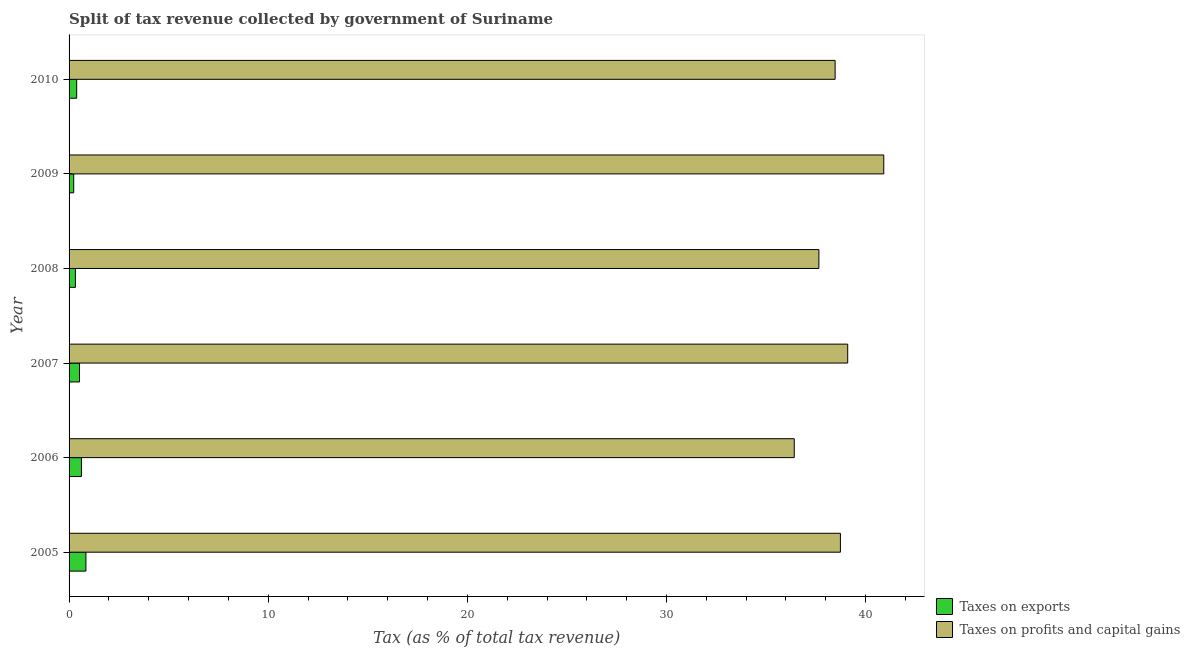How many groups of bars are there?
Your answer should be compact. 6. Are the number of bars on each tick of the Y-axis equal?
Make the answer very short. Yes. In how many cases, is the number of bars for a given year not equal to the number of legend labels?
Make the answer very short. 0. What is the percentage of revenue obtained from taxes on exports in 2008?
Offer a very short reply. 0.32. Across all years, what is the maximum percentage of revenue obtained from taxes on profits and capital gains?
Your response must be concise. 40.91. Across all years, what is the minimum percentage of revenue obtained from taxes on profits and capital gains?
Offer a very short reply. 36.42. What is the total percentage of revenue obtained from taxes on exports in the graph?
Your response must be concise. 2.92. What is the difference between the percentage of revenue obtained from taxes on profits and capital gains in 2005 and that in 2007?
Your answer should be compact. -0.37. What is the difference between the percentage of revenue obtained from taxes on profits and capital gains in 2008 and the percentage of revenue obtained from taxes on exports in 2005?
Your answer should be very brief. 36.81. What is the average percentage of revenue obtained from taxes on exports per year?
Offer a terse response. 0.49. In the year 2010, what is the difference between the percentage of revenue obtained from taxes on profits and capital gains and percentage of revenue obtained from taxes on exports?
Provide a short and direct response. 38.09. In how many years, is the percentage of revenue obtained from taxes on exports greater than 16 %?
Your answer should be compact. 0. What is the ratio of the percentage of revenue obtained from taxes on profits and capital gains in 2006 to that in 2009?
Ensure brevity in your answer.  0.89. Is the difference between the percentage of revenue obtained from taxes on exports in 2009 and 2010 greater than the difference between the percentage of revenue obtained from taxes on profits and capital gains in 2009 and 2010?
Give a very brief answer. No. What is the difference between the highest and the second highest percentage of revenue obtained from taxes on profits and capital gains?
Ensure brevity in your answer.  1.81. What is the difference between the highest and the lowest percentage of revenue obtained from taxes on profits and capital gains?
Ensure brevity in your answer.  4.49. In how many years, is the percentage of revenue obtained from taxes on profits and capital gains greater than the average percentage of revenue obtained from taxes on profits and capital gains taken over all years?
Offer a very short reply. 3. Is the sum of the percentage of revenue obtained from taxes on profits and capital gains in 2007 and 2008 greater than the maximum percentage of revenue obtained from taxes on exports across all years?
Keep it short and to the point. Yes. What does the 1st bar from the top in 2006 represents?
Your answer should be compact. Taxes on profits and capital gains. What does the 1st bar from the bottom in 2005 represents?
Keep it short and to the point. Taxes on exports. How many bars are there?
Provide a short and direct response. 12. Are all the bars in the graph horizontal?
Offer a terse response. Yes. How many years are there in the graph?
Offer a terse response. 6. What is the difference between two consecutive major ticks on the X-axis?
Offer a very short reply. 10. Are the values on the major ticks of X-axis written in scientific E-notation?
Ensure brevity in your answer.  No. Does the graph contain any zero values?
Offer a very short reply. No. Does the graph contain grids?
Provide a succinct answer. No. How many legend labels are there?
Make the answer very short. 2. How are the legend labels stacked?
Your answer should be very brief. Vertical. What is the title of the graph?
Your answer should be compact. Split of tax revenue collected by government of Suriname. Does "Health Care" appear as one of the legend labels in the graph?
Offer a terse response. No. What is the label or title of the X-axis?
Your answer should be very brief. Tax (as % of total tax revenue). What is the Tax (as % of total tax revenue) in Taxes on exports in 2005?
Your response must be concise. 0.85. What is the Tax (as % of total tax revenue) of Taxes on profits and capital gains in 2005?
Your response must be concise. 38.73. What is the Tax (as % of total tax revenue) in Taxes on exports in 2006?
Provide a short and direct response. 0.62. What is the Tax (as % of total tax revenue) in Taxes on profits and capital gains in 2006?
Provide a short and direct response. 36.42. What is the Tax (as % of total tax revenue) in Taxes on exports in 2007?
Give a very brief answer. 0.52. What is the Tax (as % of total tax revenue) of Taxes on profits and capital gains in 2007?
Your response must be concise. 39.1. What is the Tax (as % of total tax revenue) of Taxes on exports in 2008?
Offer a very short reply. 0.32. What is the Tax (as % of total tax revenue) of Taxes on profits and capital gains in 2008?
Provide a short and direct response. 37.65. What is the Tax (as % of total tax revenue) of Taxes on exports in 2009?
Ensure brevity in your answer.  0.23. What is the Tax (as % of total tax revenue) of Taxes on profits and capital gains in 2009?
Your response must be concise. 40.91. What is the Tax (as % of total tax revenue) in Taxes on exports in 2010?
Keep it short and to the point. 0.38. What is the Tax (as % of total tax revenue) in Taxes on profits and capital gains in 2010?
Your answer should be compact. 38.47. Across all years, what is the maximum Tax (as % of total tax revenue) of Taxes on exports?
Provide a short and direct response. 0.85. Across all years, what is the maximum Tax (as % of total tax revenue) in Taxes on profits and capital gains?
Your response must be concise. 40.91. Across all years, what is the minimum Tax (as % of total tax revenue) in Taxes on exports?
Keep it short and to the point. 0.23. Across all years, what is the minimum Tax (as % of total tax revenue) in Taxes on profits and capital gains?
Make the answer very short. 36.42. What is the total Tax (as % of total tax revenue) of Taxes on exports in the graph?
Your answer should be compact. 2.92. What is the total Tax (as % of total tax revenue) in Taxes on profits and capital gains in the graph?
Make the answer very short. 231.28. What is the difference between the Tax (as % of total tax revenue) of Taxes on exports in 2005 and that in 2006?
Keep it short and to the point. 0.23. What is the difference between the Tax (as % of total tax revenue) of Taxes on profits and capital gains in 2005 and that in 2006?
Offer a very short reply. 2.32. What is the difference between the Tax (as % of total tax revenue) of Taxes on exports in 2005 and that in 2007?
Provide a succinct answer. 0.32. What is the difference between the Tax (as % of total tax revenue) in Taxes on profits and capital gains in 2005 and that in 2007?
Ensure brevity in your answer.  -0.37. What is the difference between the Tax (as % of total tax revenue) of Taxes on exports in 2005 and that in 2008?
Provide a short and direct response. 0.53. What is the difference between the Tax (as % of total tax revenue) of Taxes on profits and capital gains in 2005 and that in 2008?
Your response must be concise. 1.08. What is the difference between the Tax (as % of total tax revenue) in Taxes on exports in 2005 and that in 2009?
Provide a succinct answer. 0.61. What is the difference between the Tax (as % of total tax revenue) of Taxes on profits and capital gains in 2005 and that in 2009?
Provide a succinct answer. -2.18. What is the difference between the Tax (as % of total tax revenue) of Taxes on exports in 2005 and that in 2010?
Your response must be concise. 0.46. What is the difference between the Tax (as % of total tax revenue) in Taxes on profits and capital gains in 2005 and that in 2010?
Provide a succinct answer. 0.27. What is the difference between the Tax (as % of total tax revenue) of Taxes on exports in 2006 and that in 2007?
Your response must be concise. 0.1. What is the difference between the Tax (as % of total tax revenue) of Taxes on profits and capital gains in 2006 and that in 2007?
Offer a terse response. -2.68. What is the difference between the Tax (as % of total tax revenue) of Taxes on exports in 2006 and that in 2008?
Provide a short and direct response. 0.3. What is the difference between the Tax (as % of total tax revenue) of Taxes on profits and capital gains in 2006 and that in 2008?
Provide a succinct answer. -1.24. What is the difference between the Tax (as % of total tax revenue) in Taxes on exports in 2006 and that in 2009?
Make the answer very short. 0.39. What is the difference between the Tax (as % of total tax revenue) in Taxes on profits and capital gains in 2006 and that in 2009?
Provide a short and direct response. -4.49. What is the difference between the Tax (as % of total tax revenue) of Taxes on exports in 2006 and that in 2010?
Your response must be concise. 0.24. What is the difference between the Tax (as % of total tax revenue) of Taxes on profits and capital gains in 2006 and that in 2010?
Provide a succinct answer. -2.05. What is the difference between the Tax (as % of total tax revenue) of Taxes on exports in 2007 and that in 2008?
Ensure brevity in your answer.  0.2. What is the difference between the Tax (as % of total tax revenue) of Taxes on profits and capital gains in 2007 and that in 2008?
Your answer should be very brief. 1.45. What is the difference between the Tax (as % of total tax revenue) of Taxes on exports in 2007 and that in 2009?
Keep it short and to the point. 0.29. What is the difference between the Tax (as % of total tax revenue) of Taxes on profits and capital gains in 2007 and that in 2009?
Ensure brevity in your answer.  -1.81. What is the difference between the Tax (as % of total tax revenue) in Taxes on exports in 2007 and that in 2010?
Make the answer very short. 0.14. What is the difference between the Tax (as % of total tax revenue) in Taxes on profits and capital gains in 2007 and that in 2010?
Provide a short and direct response. 0.63. What is the difference between the Tax (as % of total tax revenue) in Taxes on exports in 2008 and that in 2009?
Keep it short and to the point. 0.09. What is the difference between the Tax (as % of total tax revenue) in Taxes on profits and capital gains in 2008 and that in 2009?
Provide a succinct answer. -3.26. What is the difference between the Tax (as % of total tax revenue) of Taxes on exports in 2008 and that in 2010?
Give a very brief answer. -0.06. What is the difference between the Tax (as % of total tax revenue) of Taxes on profits and capital gains in 2008 and that in 2010?
Your answer should be very brief. -0.81. What is the difference between the Tax (as % of total tax revenue) of Taxes on exports in 2009 and that in 2010?
Provide a succinct answer. -0.15. What is the difference between the Tax (as % of total tax revenue) in Taxes on profits and capital gains in 2009 and that in 2010?
Keep it short and to the point. 2.44. What is the difference between the Tax (as % of total tax revenue) of Taxes on exports in 2005 and the Tax (as % of total tax revenue) of Taxes on profits and capital gains in 2006?
Keep it short and to the point. -35.57. What is the difference between the Tax (as % of total tax revenue) of Taxes on exports in 2005 and the Tax (as % of total tax revenue) of Taxes on profits and capital gains in 2007?
Provide a succinct answer. -38.25. What is the difference between the Tax (as % of total tax revenue) in Taxes on exports in 2005 and the Tax (as % of total tax revenue) in Taxes on profits and capital gains in 2008?
Offer a very short reply. -36.81. What is the difference between the Tax (as % of total tax revenue) of Taxes on exports in 2005 and the Tax (as % of total tax revenue) of Taxes on profits and capital gains in 2009?
Your answer should be very brief. -40.06. What is the difference between the Tax (as % of total tax revenue) of Taxes on exports in 2005 and the Tax (as % of total tax revenue) of Taxes on profits and capital gains in 2010?
Keep it short and to the point. -37.62. What is the difference between the Tax (as % of total tax revenue) in Taxes on exports in 2006 and the Tax (as % of total tax revenue) in Taxes on profits and capital gains in 2007?
Provide a succinct answer. -38.48. What is the difference between the Tax (as % of total tax revenue) in Taxes on exports in 2006 and the Tax (as % of total tax revenue) in Taxes on profits and capital gains in 2008?
Your response must be concise. -37.03. What is the difference between the Tax (as % of total tax revenue) of Taxes on exports in 2006 and the Tax (as % of total tax revenue) of Taxes on profits and capital gains in 2009?
Offer a very short reply. -40.29. What is the difference between the Tax (as % of total tax revenue) in Taxes on exports in 2006 and the Tax (as % of total tax revenue) in Taxes on profits and capital gains in 2010?
Offer a terse response. -37.85. What is the difference between the Tax (as % of total tax revenue) of Taxes on exports in 2007 and the Tax (as % of total tax revenue) of Taxes on profits and capital gains in 2008?
Give a very brief answer. -37.13. What is the difference between the Tax (as % of total tax revenue) of Taxes on exports in 2007 and the Tax (as % of total tax revenue) of Taxes on profits and capital gains in 2009?
Keep it short and to the point. -40.39. What is the difference between the Tax (as % of total tax revenue) in Taxes on exports in 2007 and the Tax (as % of total tax revenue) in Taxes on profits and capital gains in 2010?
Offer a very short reply. -37.95. What is the difference between the Tax (as % of total tax revenue) in Taxes on exports in 2008 and the Tax (as % of total tax revenue) in Taxes on profits and capital gains in 2009?
Offer a terse response. -40.59. What is the difference between the Tax (as % of total tax revenue) in Taxes on exports in 2008 and the Tax (as % of total tax revenue) in Taxes on profits and capital gains in 2010?
Your response must be concise. -38.15. What is the difference between the Tax (as % of total tax revenue) of Taxes on exports in 2009 and the Tax (as % of total tax revenue) of Taxes on profits and capital gains in 2010?
Offer a terse response. -38.23. What is the average Tax (as % of total tax revenue) in Taxes on exports per year?
Offer a very short reply. 0.49. What is the average Tax (as % of total tax revenue) of Taxes on profits and capital gains per year?
Make the answer very short. 38.55. In the year 2005, what is the difference between the Tax (as % of total tax revenue) in Taxes on exports and Tax (as % of total tax revenue) in Taxes on profits and capital gains?
Keep it short and to the point. -37.89. In the year 2006, what is the difference between the Tax (as % of total tax revenue) in Taxes on exports and Tax (as % of total tax revenue) in Taxes on profits and capital gains?
Offer a terse response. -35.79. In the year 2007, what is the difference between the Tax (as % of total tax revenue) in Taxes on exports and Tax (as % of total tax revenue) in Taxes on profits and capital gains?
Make the answer very short. -38.58. In the year 2008, what is the difference between the Tax (as % of total tax revenue) in Taxes on exports and Tax (as % of total tax revenue) in Taxes on profits and capital gains?
Provide a succinct answer. -37.34. In the year 2009, what is the difference between the Tax (as % of total tax revenue) in Taxes on exports and Tax (as % of total tax revenue) in Taxes on profits and capital gains?
Offer a terse response. -40.68. In the year 2010, what is the difference between the Tax (as % of total tax revenue) of Taxes on exports and Tax (as % of total tax revenue) of Taxes on profits and capital gains?
Provide a succinct answer. -38.09. What is the ratio of the Tax (as % of total tax revenue) in Taxes on exports in 2005 to that in 2006?
Your response must be concise. 1.36. What is the ratio of the Tax (as % of total tax revenue) of Taxes on profits and capital gains in 2005 to that in 2006?
Your answer should be compact. 1.06. What is the ratio of the Tax (as % of total tax revenue) of Taxes on exports in 2005 to that in 2007?
Your answer should be compact. 1.62. What is the ratio of the Tax (as % of total tax revenue) of Taxes on profits and capital gains in 2005 to that in 2007?
Offer a very short reply. 0.99. What is the ratio of the Tax (as % of total tax revenue) in Taxes on exports in 2005 to that in 2008?
Your answer should be very brief. 2.66. What is the ratio of the Tax (as % of total tax revenue) in Taxes on profits and capital gains in 2005 to that in 2008?
Make the answer very short. 1.03. What is the ratio of the Tax (as % of total tax revenue) in Taxes on exports in 2005 to that in 2009?
Give a very brief answer. 3.63. What is the ratio of the Tax (as % of total tax revenue) in Taxes on profits and capital gains in 2005 to that in 2009?
Make the answer very short. 0.95. What is the ratio of the Tax (as % of total tax revenue) in Taxes on exports in 2005 to that in 2010?
Provide a succinct answer. 2.22. What is the ratio of the Tax (as % of total tax revenue) in Taxes on exports in 2006 to that in 2007?
Make the answer very short. 1.19. What is the ratio of the Tax (as % of total tax revenue) of Taxes on profits and capital gains in 2006 to that in 2007?
Make the answer very short. 0.93. What is the ratio of the Tax (as % of total tax revenue) in Taxes on exports in 2006 to that in 2008?
Give a very brief answer. 1.95. What is the ratio of the Tax (as % of total tax revenue) in Taxes on profits and capital gains in 2006 to that in 2008?
Provide a short and direct response. 0.97. What is the ratio of the Tax (as % of total tax revenue) of Taxes on exports in 2006 to that in 2009?
Provide a succinct answer. 2.66. What is the ratio of the Tax (as % of total tax revenue) in Taxes on profits and capital gains in 2006 to that in 2009?
Ensure brevity in your answer.  0.89. What is the ratio of the Tax (as % of total tax revenue) of Taxes on exports in 2006 to that in 2010?
Offer a terse response. 1.63. What is the ratio of the Tax (as % of total tax revenue) in Taxes on profits and capital gains in 2006 to that in 2010?
Give a very brief answer. 0.95. What is the ratio of the Tax (as % of total tax revenue) in Taxes on exports in 2007 to that in 2008?
Make the answer very short. 1.64. What is the ratio of the Tax (as % of total tax revenue) of Taxes on profits and capital gains in 2007 to that in 2008?
Provide a short and direct response. 1.04. What is the ratio of the Tax (as % of total tax revenue) in Taxes on exports in 2007 to that in 2009?
Provide a succinct answer. 2.24. What is the ratio of the Tax (as % of total tax revenue) of Taxes on profits and capital gains in 2007 to that in 2009?
Your response must be concise. 0.96. What is the ratio of the Tax (as % of total tax revenue) of Taxes on exports in 2007 to that in 2010?
Make the answer very short. 1.37. What is the ratio of the Tax (as % of total tax revenue) in Taxes on profits and capital gains in 2007 to that in 2010?
Give a very brief answer. 1.02. What is the ratio of the Tax (as % of total tax revenue) of Taxes on exports in 2008 to that in 2009?
Make the answer very short. 1.37. What is the ratio of the Tax (as % of total tax revenue) in Taxes on profits and capital gains in 2008 to that in 2009?
Make the answer very short. 0.92. What is the ratio of the Tax (as % of total tax revenue) in Taxes on exports in 2008 to that in 2010?
Make the answer very short. 0.83. What is the ratio of the Tax (as % of total tax revenue) in Taxes on profits and capital gains in 2008 to that in 2010?
Give a very brief answer. 0.98. What is the ratio of the Tax (as % of total tax revenue) of Taxes on exports in 2009 to that in 2010?
Ensure brevity in your answer.  0.61. What is the ratio of the Tax (as % of total tax revenue) in Taxes on profits and capital gains in 2009 to that in 2010?
Give a very brief answer. 1.06. What is the difference between the highest and the second highest Tax (as % of total tax revenue) of Taxes on exports?
Offer a very short reply. 0.23. What is the difference between the highest and the second highest Tax (as % of total tax revenue) of Taxes on profits and capital gains?
Give a very brief answer. 1.81. What is the difference between the highest and the lowest Tax (as % of total tax revenue) of Taxes on exports?
Your response must be concise. 0.61. What is the difference between the highest and the lowest Tax (as % of total tax revenue) in Taxes on profits and capital gains?
Give a very brief answer. 4.49. 